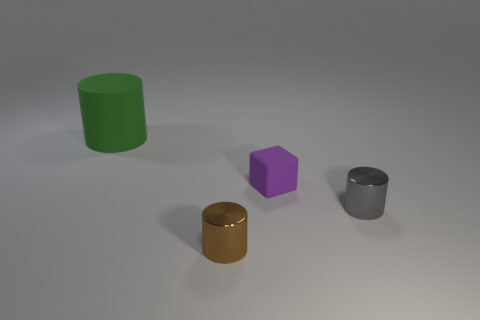What time of day does the lighting in the image suggest it is? The lighting in the image appears to be artificial and controlled, without any indicators of natural light sources that would suggest a specific time of day. The shadows are soft and diffused, which is typical for studio-like conditions. 